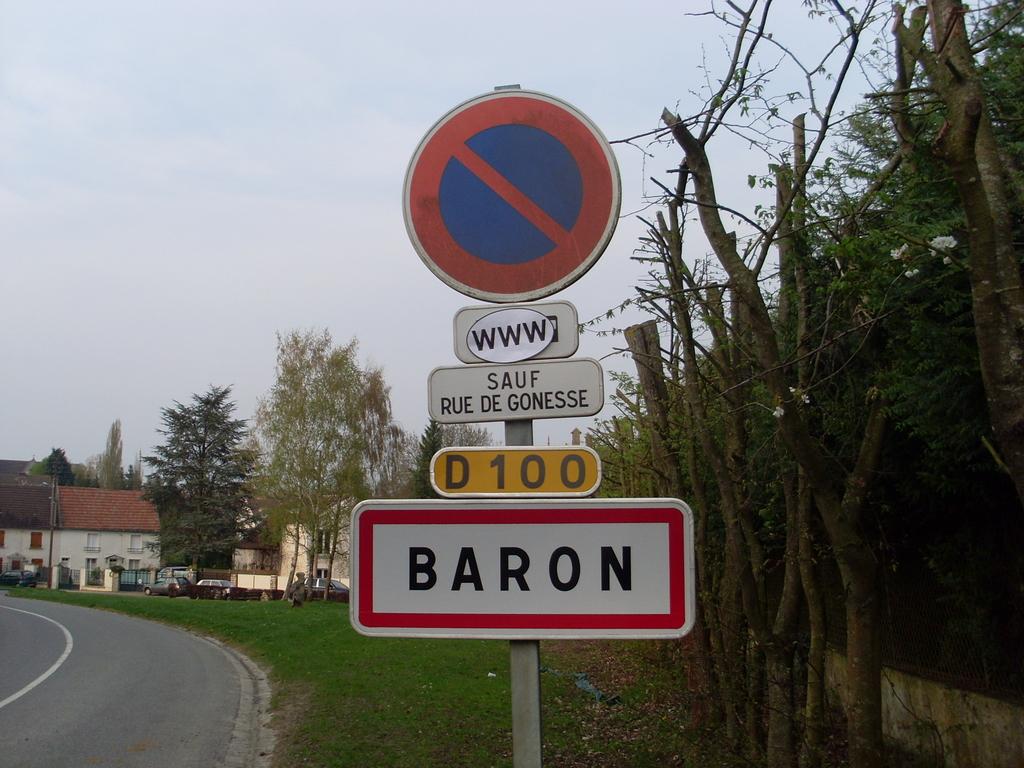What name is written on the bottom of the sign in a red border rectangle?
Your response must be concise. Baron. 